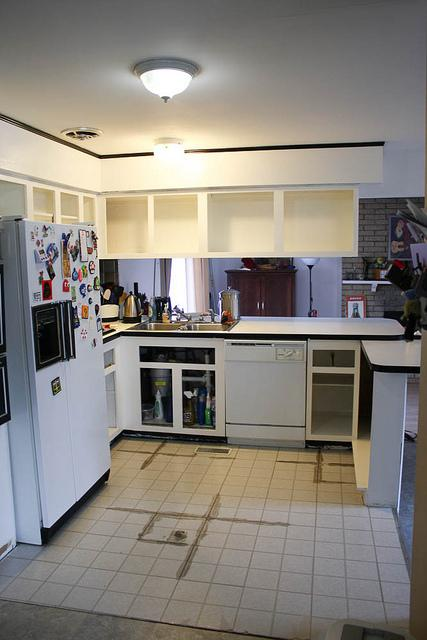What room is beyond the countertops? living room 